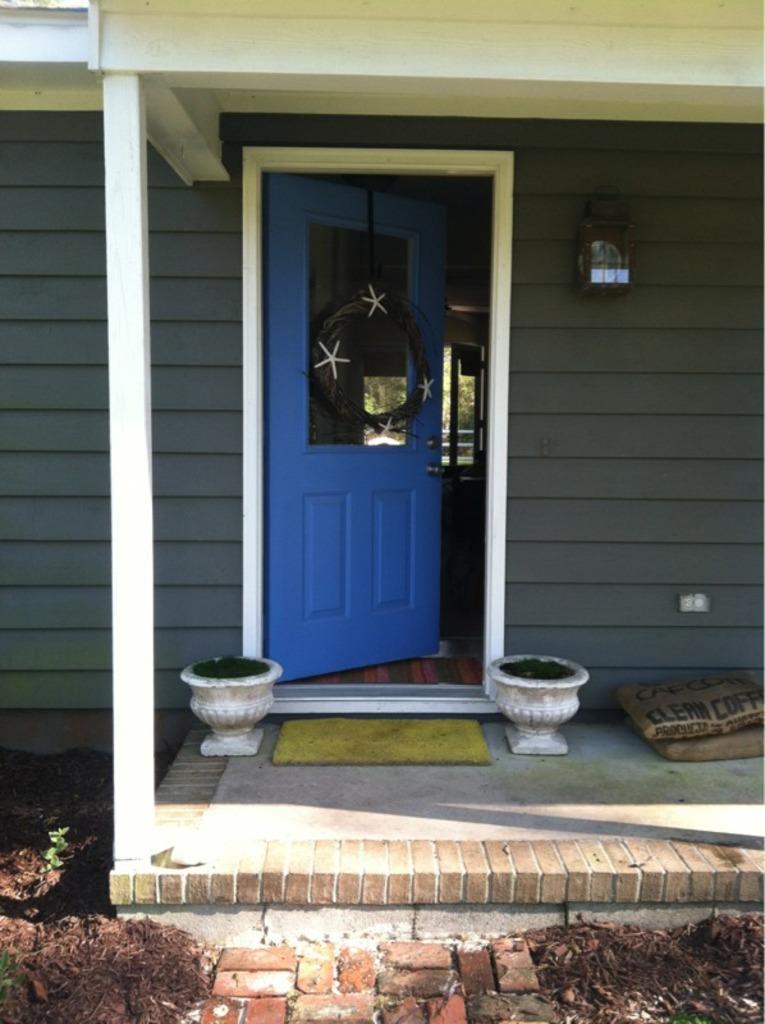Could you give a brief overview of what you see in this image? In this image there is a entrance of a house there are two pot and a door beside the point there are two bags. 